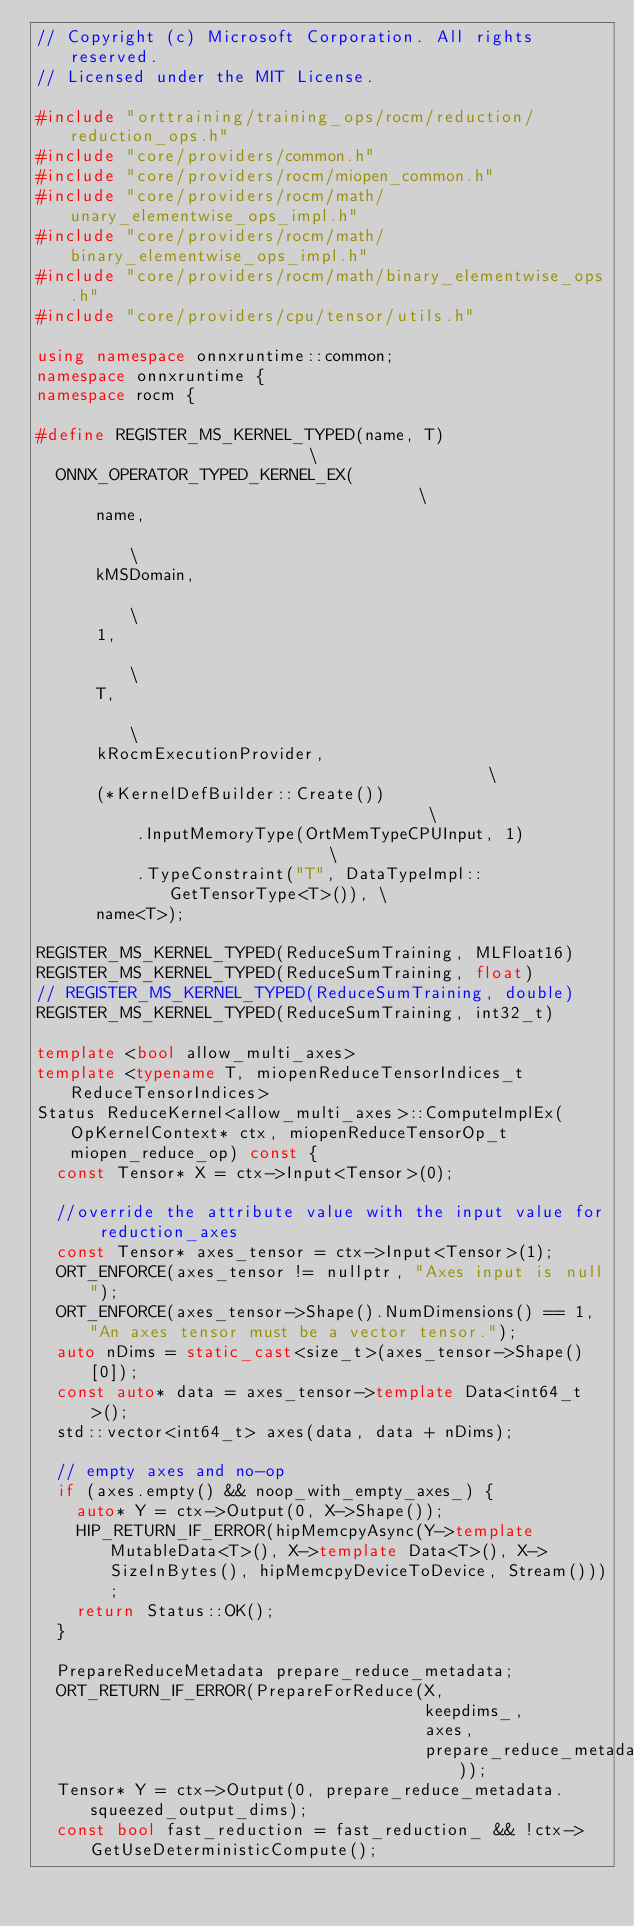Convert code to text. <code><loc_0><loc_0><loc_500><loc_500><_C++_>// Copyright (c) Microsoft Corporation. All rights reserved.
// Licensed under the MIT License.

#include "orttraining/training_ops/rocm/reduction/reduction_ops.h"
#include "core/providers/common.h"
#include "core/providers/rocm/miopen_common.h"
#include "core/providers/rocm/math/unary_elementwise_ops_impl.h"
#include "core/providers/rocm/math/binary_elementwise_ops_impl.h"
#include "core/providers/rocm/math/binary_elementwise_ops.h"
#include "core/providers/cpu/tensor/utils.h"

using namespace onnxruntime::common;
namespace onnxruntime {
namespace rocm {

#define REGISTER_MS_KERNEL_TYPED(name, T)                         \
  ONNX_OPERATOR_TYPED_KERNEL_EX(                                  \
      name,                                                       \
      kMSDomain,                                                  \
      1,                                                          \
      T,                                                          \
      kRocmExecutionProvider,                                     \
      (*KernelDefBuilder::Create())                               \
          .InputMemoryType(OrtMemTypeCPUInput, 1)                 \
          .TypeConstraint("T", DataTypeImpl::GetTensorType<T>()), \
      name<T>);

REGISTER_MS_KERNEL_TYPED(ReduceSumTraining, MLFloat16)
REGISTER_MS_KERNEL_TYPED(ReduceSumTraining, float)
// REGISTER_MS_KERNEL_TYPED(ReduceSumTraining, double)
REGISTER_MS_KERNEL_TYPED(ReduceSumTraining, int32_t)

template <bool allow_multi_axes>
template <typename T, miopenReduceTensorIndices_t ReduceTensorIndices>
Status ReduceKernel<allow_multi_axes>::ComputeImplEx(OpKernelContext* ctx, miopenReduceTensorOp_t miopen_reduce_op) const {
  const Tensor* X = ctx->Input<Tensor>(0);

  //override the attribute value with the input value for reduction_axes
  const Tensor* axes_tensor = ctx->Input<Tensor>(1);
  ORT_ENFORCE(axes_tensor != nullptr, "Axes input is null");
  ORT_ENFORCE(axes_tensor->Shape().NumDimensions() == 1, "An axes tensor must be a vector tensor.");
  auto nDims = static_cast<size_t>(axes_tensor->Shape()[0]);
  const auto* data = axes_tensor->template Data<int64_t>();
  std::vector<int64_t> axes(data, data + nDims);

  // empty axes and no-op
  if (axes.empty() && noop_with_empty_axes_) {
    auto* Y = ctx->Output(0, X->Shape());
    HIP_RETURN_IF_ERROR(hipMemcpyAsync(Y->template MutableData<T>(), X->template Data<T>(), X->SizeInBytes(), hipMemcpyDeviceToDevice, Stream()));
    return Status::OK();
  }

  PrepareReduceMetadata prepare_reduce_metadata;
  ORT_RETURN_IF_ERROR(PrepareForReduce(X,
                                       keepdims_,
                                       axes,
                                       prepare_reduce_metadata));
  Tensor* Y = ctx->Output(0, prepare_reduce_metadata.squeezed_output_dims);
  const bool fast_reduction = fast_reduction_ && !ctx->GetUseDeterministicCompute();
</code> 